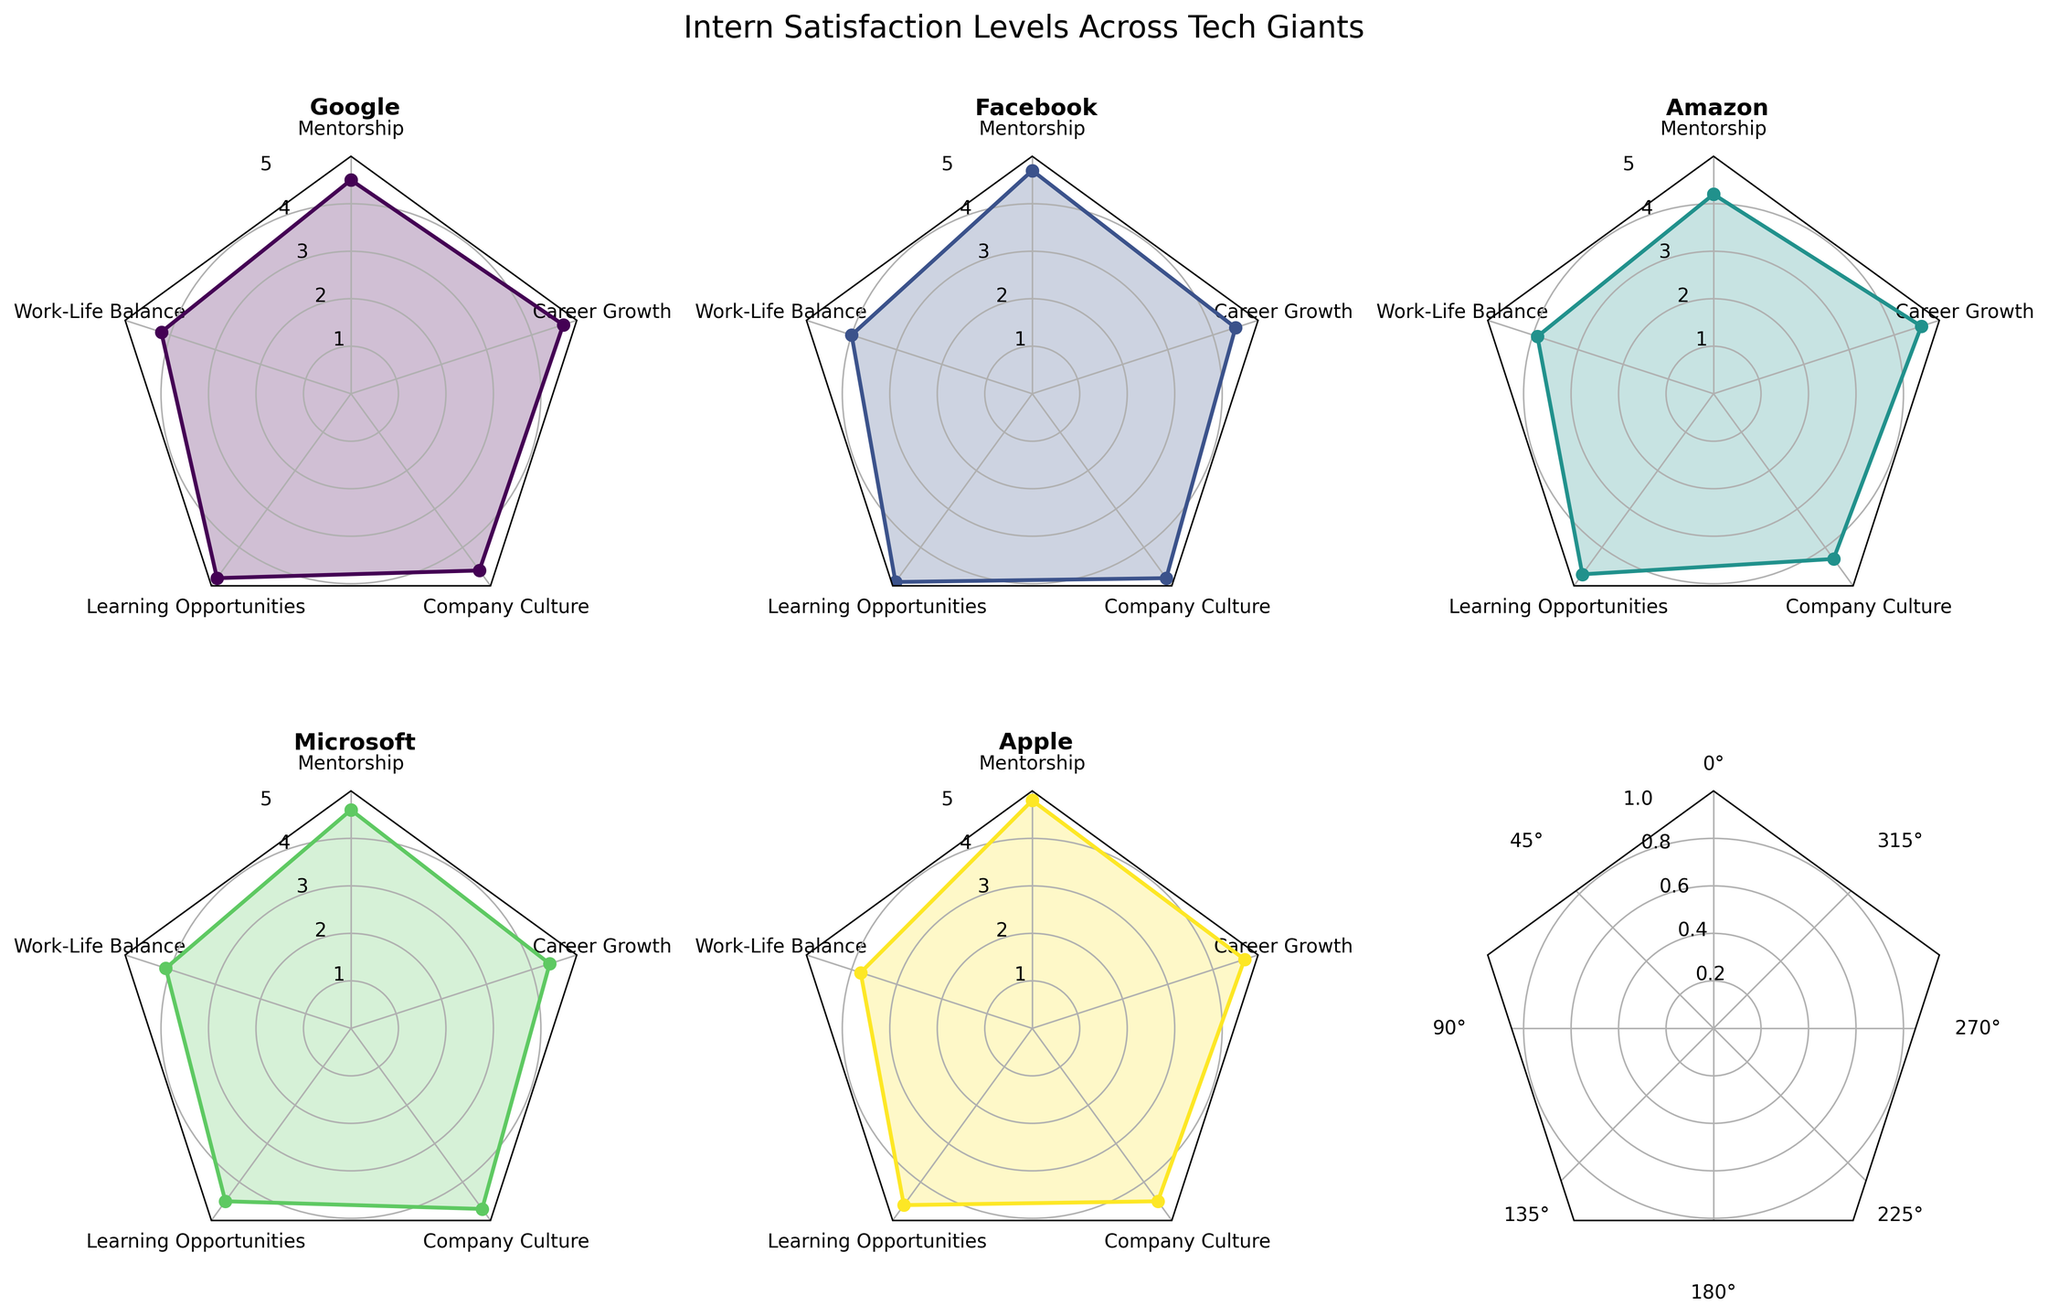What's the title of the figure? The title can be found at the top center of the figure. It summarizes the overall content shown in all subplots.
Answer: Intern Satisfaction Levels Across Tech Giants Which company received the highest rating for Work-Life Balance? Look at the subplot title for each company and check the Work-Life Balance category, which is indicated on the radar chart. Identify the company with the highest value.
Answer: Google What is the average rating for Learning Opportunities across all companies? Check the values for Learning Opportunities in each company's radar chart, sum them up (4.8 + 4.9 + 4.7 + 4.5 + 4.6) and divide by the number of companies (5).
Answer: 4.7 Which aspect has the lowest rating for Amazon? Look for the lowest point in Amazon's radar chart and identify the corresponding category label.
Answer: Work-Life Balance Which company has the most balanced ratings across all categories? Compare the shapes of all radar charts and identify the company with ratings that are most evenly distributed (i.e., closer to a regular polygon).
Answer: Google Which two companies have the most similar ratings for Mentorship? Check the Mentorship values for each company and compare them to find the two closest in value.
Answer: Microsoft and Google What is the difference in the Career Growth ratings between Facebook and Microsoft? Subtract Microsoft's Career Growth rating (4.4) from Facebook's rating (4.5).
Answer: 0.1 How do Google's Learning Opportunities ratings compare with Facebook's? Compare the Learning Opportunities ratings from Google's and Facebook's radar charts.
Answer: Google is lower Which company's ratings for Company Culture exceed 4.5? Look at the value for Company Culture in each company's radar chart and identify those greater than 4.5.
Answer: Facebook and Microsoft 